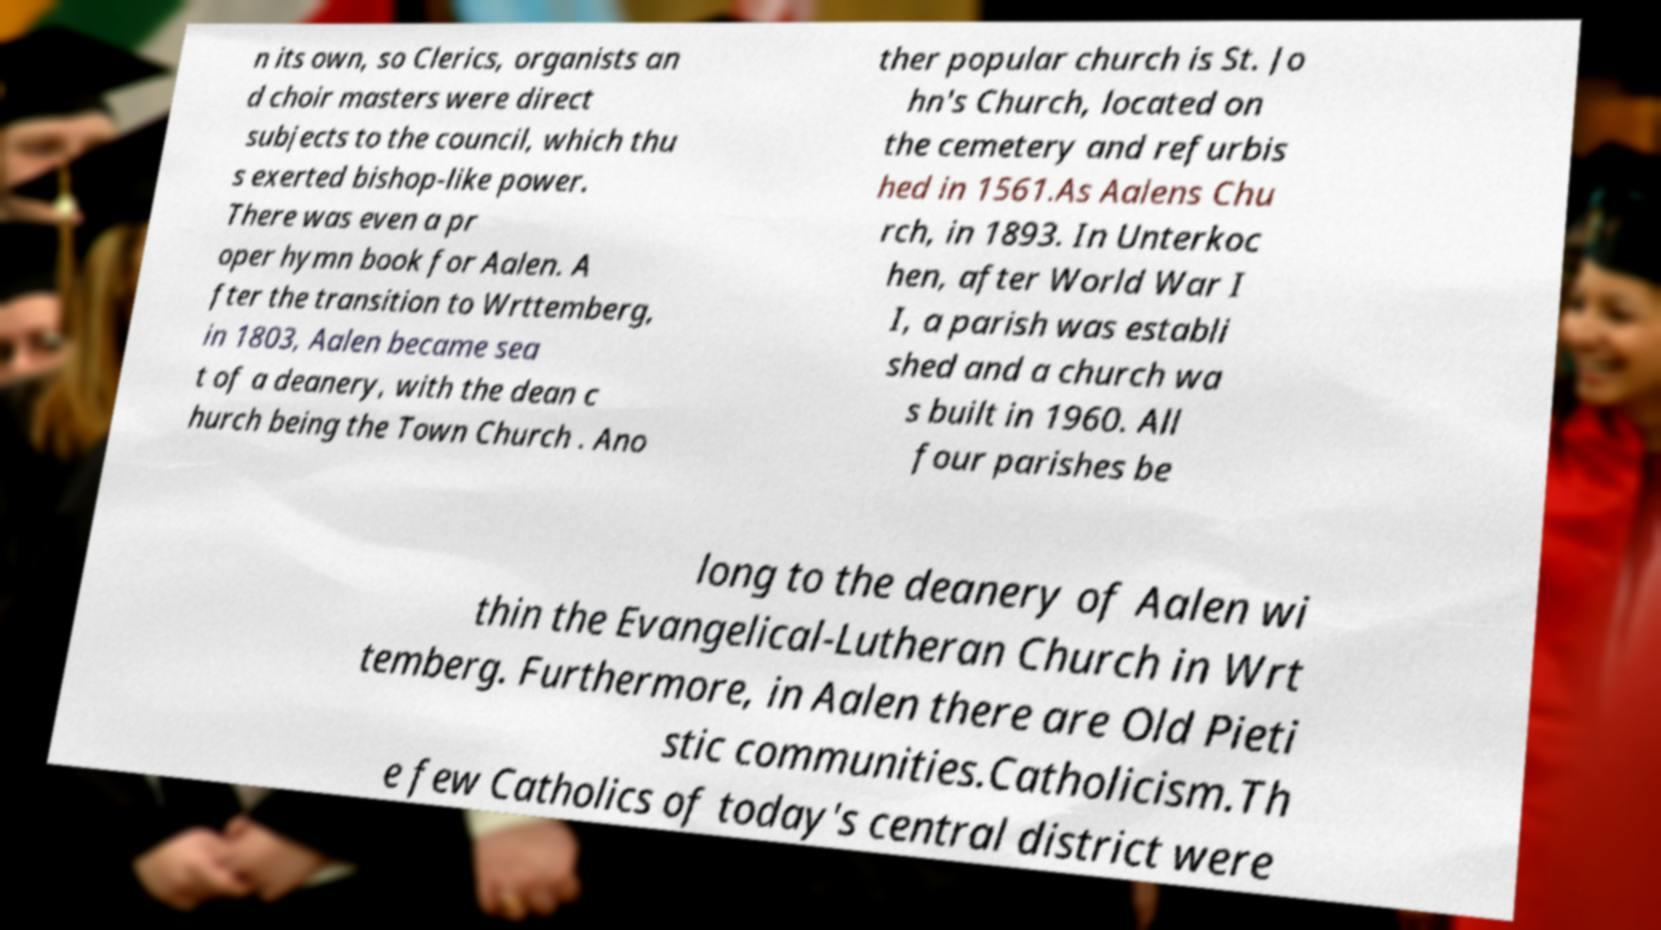I need the written content from this picture converted into text. Can you do that? n its own, so Clerics, organists an d choir masters were direct subjects to the council, which thu s exerted bishop-like power. There was even a pr oper hymn book for Aalen. A fter the transition to Wrttemberg, in 1803, Aalen became sea t of a deanery, with the dean c hurch being the Town Church . Ano ther popular church is St. Jo hn's Church, located on the cemetery and refurbis hed in 1561.As Aalens Chu rch, in 1893. In Unterkoc hen, after World War I I, a parish was establi shed and a church wa s built in 1960. All four parishes be long to the deanery of Aalen wi thin the Evangelical-Lutheran Church in Wrt temberg. Furthermore, in Aalen there are Old Pieti stic communities.Catholicism.Th e few Catholics of today's central district were 